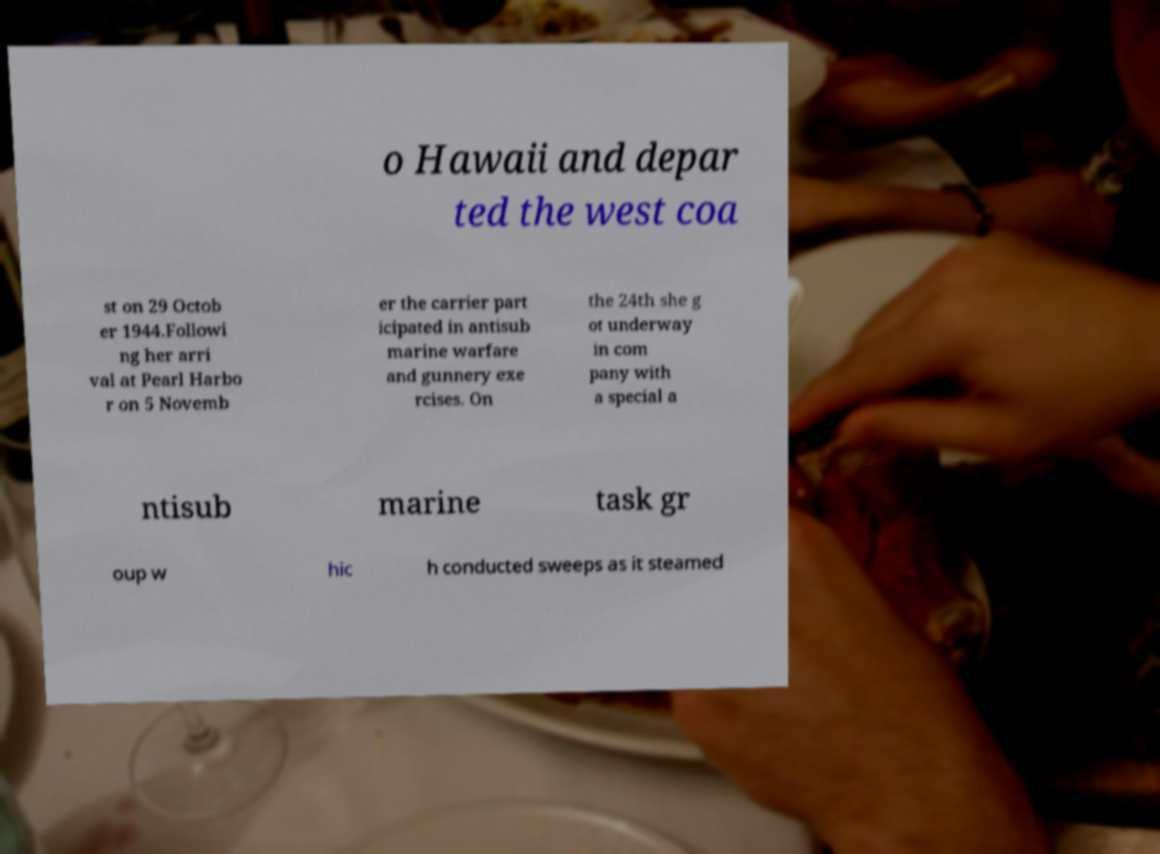Could you extract and type out the text from this image? o Hawaii and depar ted the west coa st on 29 Octob er 1944.Followi ng her arri val at Pearl Harbo r on 5 Novemb er the carrier part icipated in antisub marine warfare and gunnery exe rcises. On the 24th she g ot underway in com pany with a special a ntisub marine task gr oup w hic h conducted sweeps as it steamed 